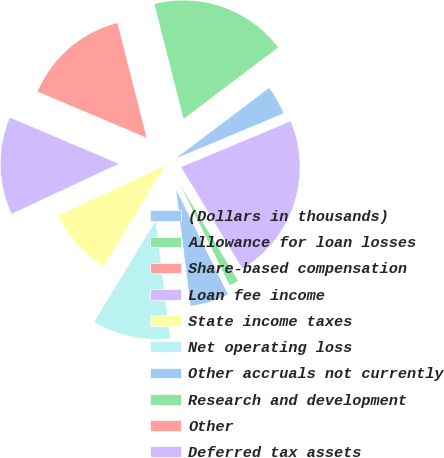Convert chart to OTSL. <chart><loc_0><loc_0><loc_500><loc_500><pie_chart><fcel>(Dollars in thousands)<fcel>Allowance for loan losses<fcel>Share-based compensation<fcel>Loan fee income<fcel>State income taxes<fcel>Net operating loss<fcel>Other accruals not currently<fcel>Research and development<fcel>Other<fcel>Deferred tax assets<nl><fcel>4.0%<fcel>18.66%<fcel>14.67%<fcel>13.33%<fcel>9.33%<fcel>10.67%<fcel>5.33%<fcel>1.34%<fcel>0.0%<fcel>22.66%<nl></chart> 